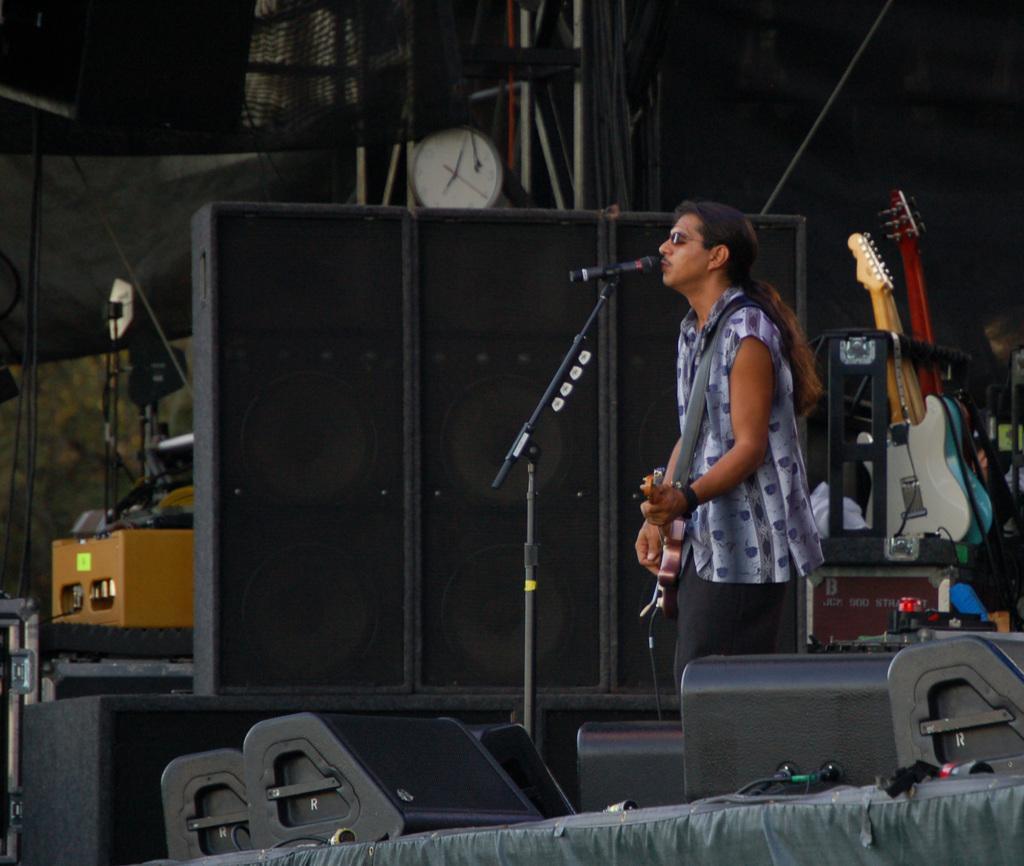Could you give a brief overview of what you see in this image? In the image we can see there is a man who is holding a guitar and he is standing in front of a mike and beside him there are three speaker boxes and he is standing on the stage. At the back there are two guitars and there is a clock over here. 